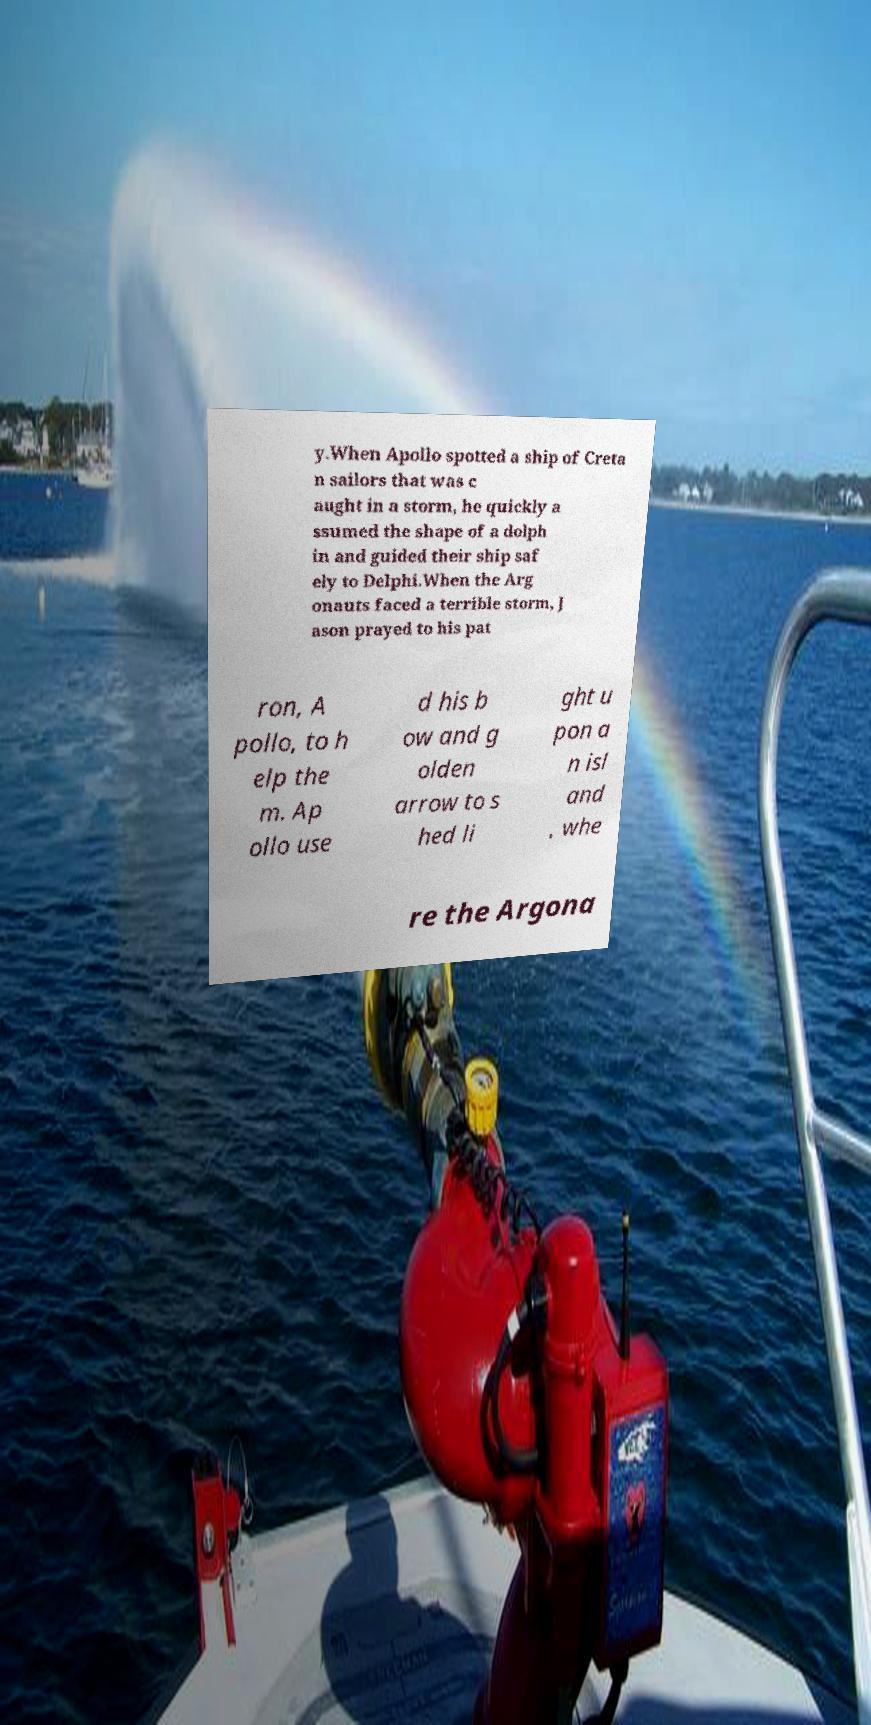For documentation purposes, I need the text within this image transcribed. Could you provide that? y.When Apollo spotted a ship of Creta n sailors that was c aught in a storm, he quickly a ssumed the shape of a dolph in and guided their ship saf ely to Delphi.When the Arg onauts faced a terrible storm, J ason prayed to his pat ron, A pollo, to h elp the m. Ap ollo use d his b ow and g olden arrow to s hed li ght u pon a n isl and , whe re the Argona 